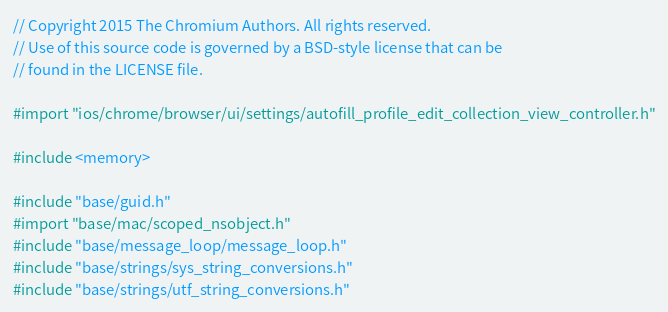Convert code to text. <code><loc_0><loc_0><loc_500><loc_500><_ObjectiveC_>// Copyright 2015 The Chromium Authors. All rights reserved.
// Use of this source code is governed by a BSD-style license that can be
// found in the LICENSE file.

#import "ios/chrome/browser/ui/settings/autofill_profile_edit_collection_view_controller.h"

#include <memory>

#include "base/guid.h"
#import "base/mac/scoped_nsobject.h"
#include "base/message_loop/message_loop.h"
#include "base/strings/sys_string_conversions.h"
#include "base/strings/utf_string_conversions.h"</code> 